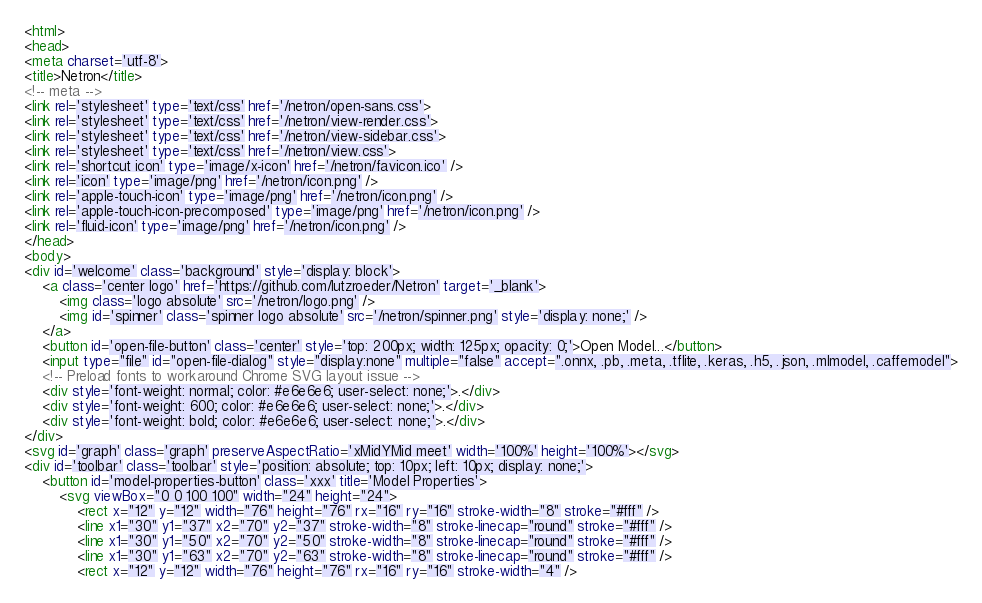Convert code to text. <code><loc_0><loc_0><loc_500><loc_500><_HTML_><html>
<head>
<meta charset='utf-8'>
<title>Netron</title>
<!-- meta -->
<link rel='stylesheet' type='text/css' href='/netron/open-sans.css'>
<link rel='stylesheet' type='text/css' href='/netron/view-render.css'>
<link rel='stylesheet' type='text/css' href='/netron/view-sidebar.css'>
<link rel='stylesheet' type='text/css' href='/netron/view.css'>
<link rel='shortcut icon' type='image/x-icon' href='/netron/favicon.ico' />
<link rel='icon' type='image/png' href='/netron/icon.png' />
<link rel='apple-touch-icon' type='image/png' href='/netron/icon.png' />
<link rel='apple-touch-icon-precomposed' type='image/png' href='/netron/icon.png' />
<link rel='fluid-icon' type='image/png' href='/netron/icon.png' />
</head>
<body>
<div id='welcome' class='background' style='display: block'>
    <a class='center logo' href='https://github.com/lutzroeder/Netron' target='_blank'>
        <img class='logo absolute' src='/netron/logo.png' />
        <img id='spinner' class='spinner logo absolute' src='/netron/spinner.png' style='display: none;' />
    </a>
    <button id='open-file-button' class='center' style='top: 200px; width: 125px; opacity: 0;'>Open Model...</button>
    <input type="file" id="open-file-dialog" style="display:none" multiple="false" accept=".onnx, .pb, .meta, .tflite, .keras, .h5, .json, .mlmodel, .caffemodel">
    <!-- Preload fonts to workaround Chrome SVG layout issue -->
    <div style='font-weight: normal; color: #e6e6e6; user-select: none;'>.</div>
    <div style='font-weight: 600; color: #e6e6e6; user-select: none;'>.</div>
    <div style='font-weight: bold; color: #e6e6e6; user-select: none;'>.</div>
</div>
<svg id='graph' class='graph' preserveAspectRatio='xMidYMid meet' width='100%' height='100%'></svg>
<div id='toolbar' class='toolbar' style='position: absolute; top: 10px; left: 10px; display: none;'>
    <button id='model-properties-button' class='xxx' title='Model Properties'>
        <svg viewBox="0 0 100 100" width="24" height="24">
            <rect x="12" y="12" width="76" height="76" rx="16" ry="16" stroke-width="8" stroke="#fff" />
            <line x1="30" y1="37" x2="70" y2="37" stroke-width="8" stroke-linecap="round" stroke="#fff" />
            <line x1="30" y1="50" x2="70" y2="50" stroke-width="8" stroke-linecap="round" stroke="#fff" />
            <line x1="30" y1="63" x2="70" y2="63" stroke-width="8" stroke-linecap="round" stroke="#fff" />
            <rect x="12" y="12" width="76" height="76" rx="16" ry="16" stroke-width="4" /></code> 